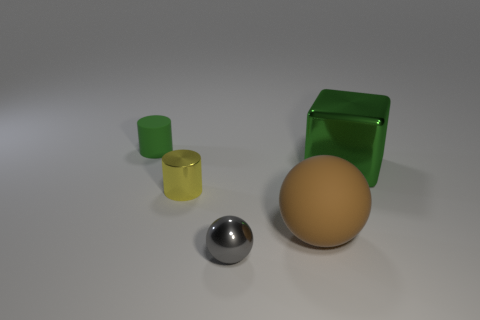The big shiny object that is the same color as the tiny rubber object is what shape?
Give a very brief answer. Cube. What is the color of the matte object that is the same shape as the yellow metal thing?
Provide a succinct answer. Green. The yellow thing that is the same shape as the tiny green thing is what size?
Your answer should be very brief. Small. There is a green thing that is on the right side of the gray object; what is it made of?
Make the answer very short. Metal. Are there fewer gray metallic spheres that are in front of the yellow cylinder than large brown metallic spheres?
Offer a very short reply. No. There is a green object in front of the matte thing behind the big shiny thing; what is its shape?
Your response must be concise. Cube. The cube has what color?
Provide a short and direct response. Green. What number of other things are the same size as the yellow cylinder?
Give a very brief answer. 2. What is the thing that is behind the small yellow cylinder and left of the big green metallic object made of?
Provide a succinct answer. Rubber. There is a matte object that is behind the metal block; is it the same size as the yellow cylinder?
Your answer should be compact. Yes. 